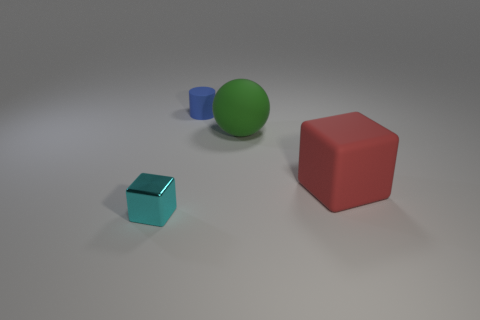Add 3 big brown things. How many objects exist? 7 Subtract all small rubber cylinders. Subtract all blue spheres. How many objects are left? 3 Add 2 large green objects. How many large green objects are left? 3 Add 1 small red cubes. How many small red cubes exist? 1 Subtract 0 yellow balls. How many objects are left? 4 Subtract all purple cylinders. Subtract all yellow cubes. How many cylinders are left? 1 